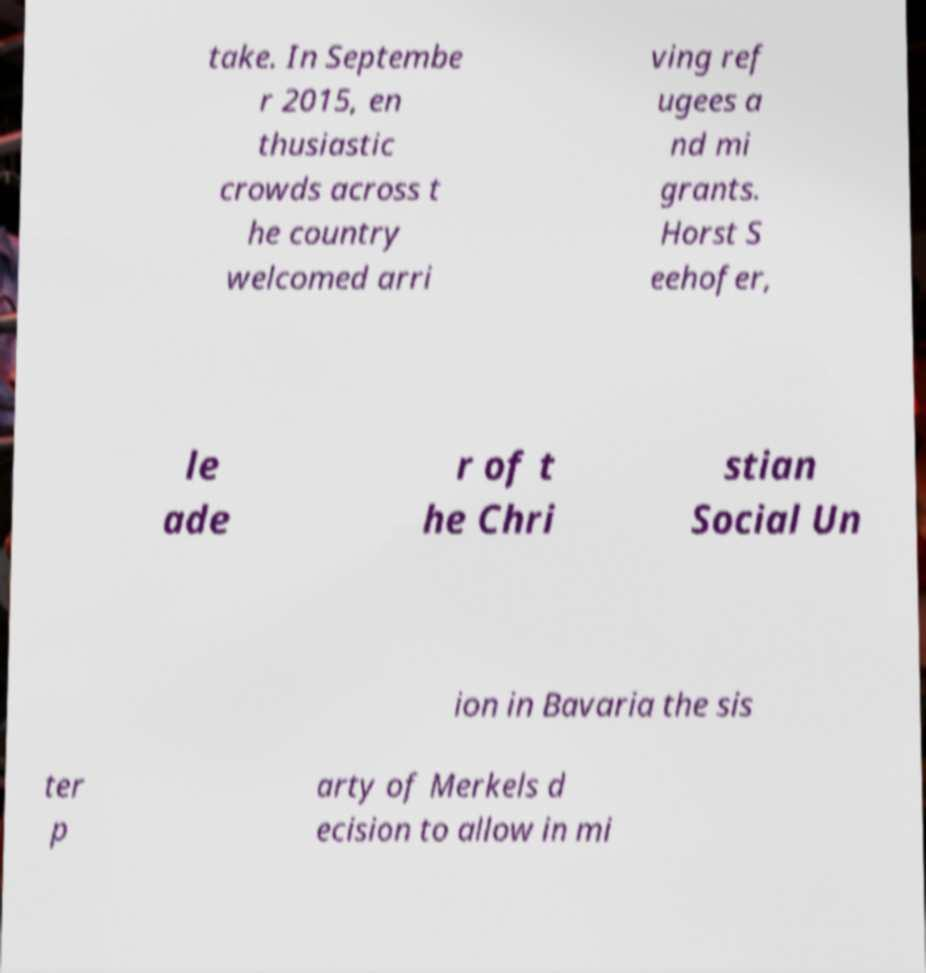Can you read and provide the text displayed in the image?This photo seems to have some interesting text. Can you extract and type it out for me? take. In Septembe r 2015, en thusiastic crowds across t he country welcomed arri ving ref ugees a nd mi grants. Horst S eehofer, le ade r of t he Chri stian Social Un ion in Bavaria the sis ter p arty of Merkels d ecision to allow in mi 